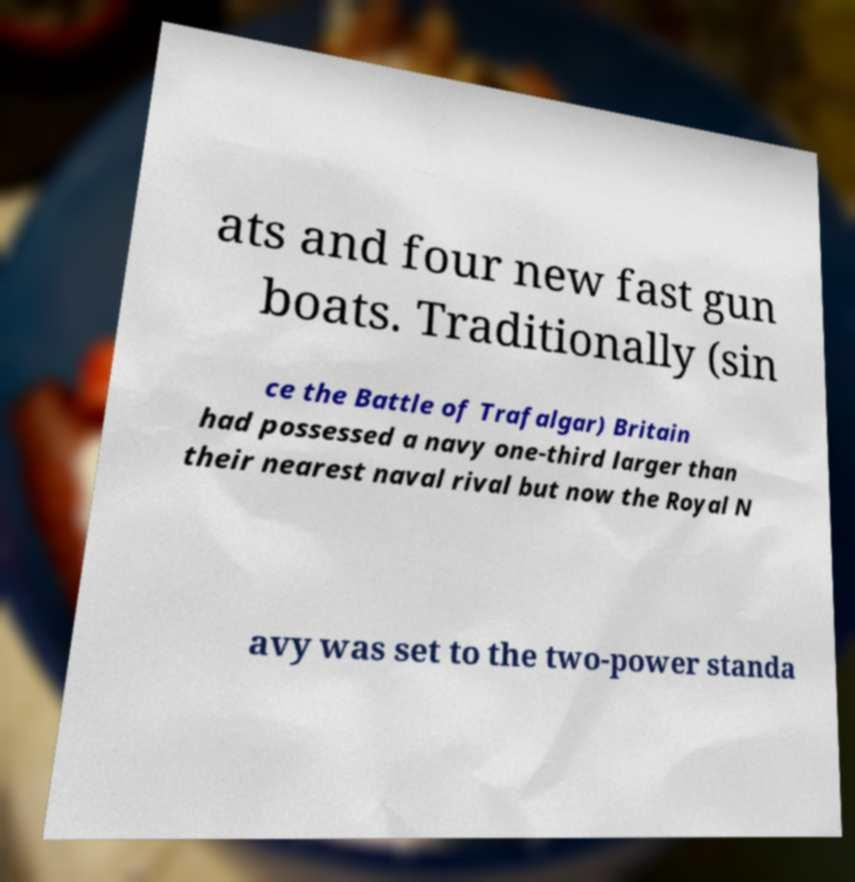Can you accurately transcribe the text from the provided image for me? ats and four new fast gun boats. Traditionally (sin ce the Battle of Trafalgar) Britain had possessed a navy one-third larger than their nearest naval rival but now the Royal N avy was set to the two-power standa 